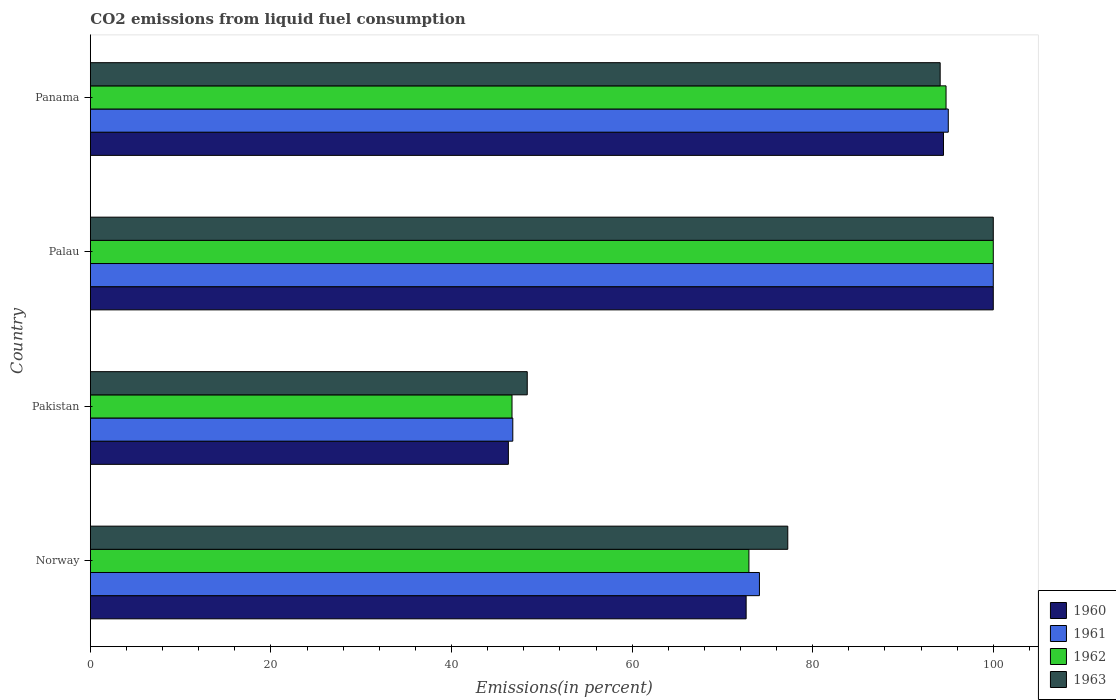How many different coloured bars are there?
Provide a short and direct response. 4. Are the number of bars per tick equal to the number of legend labels?
Provide a succinct answer. Yes. How many bars are there on the 1st tick from the bottom?
Provide a succinct answer. 4. In how many cases, is the number of bars for a given country not equal to the number of legend labels?
Provide a short and direct response. 0. What is the total CO2 emitted in 1960 in Norway?
Ensure brevity in your answer.  72.63. Across all countries, what is the maximum total CO2 emitted in 1960?
Provide a succinct answer. 100. Across all countries, what is the minimum total CO2 emitted in 1962?
Your response must be concise. 46.7. In which country was the total CO2 emitted in 1962 maximum?
Ensure brevity in your answer.  Palau. What is the total total CO2 emitted in 1962 in the graph?
Offer a very short reply. 314.4. What is the difference between the total CO2 emitted in 1962 in Norway and that in Pakistan?
Provide a short and direct response. 26.24. What is the difference between the total CO2 emitted in 1963 in Palau and the total CO2 emitted in 1960 in Norway?
Make the answer very short. 27.37. What is the average total CO2 emitted in 1960 per country?
Ensure brevity in your answer.  78.35. What is the difference between the total CO2 emitted in 1961 and total CO2 emitted in 1963 in Norway?
Your answer should be compact. -3.14. In how many countries, is the total CO2 emitted in 1962 greater than 44 %?
Offer a terse response. 4. What is the ratio of the total CO2 emitted in 1963 in Palau to that in Panama?
Make the answer very short. 1.06. What is the difference between the highest and the second highest total CO2 emitted in 1960?
Keep it short and to the point. 5.51. What is the difference between the highest and the lowest total CO2 emitted in 1962?
Ensure brevity in your answer.  53.3. What does the 2nd bar from the bottom in Norway represents?
Offer a very short reply. 1961. How many countries are there in the graph?
Keep it short and to the point. 4. What is the difference between two consecutive major ticks on the X-axis?
Your response must be concise. 20. Does the graph contain any zero values?
Give a very brief answer. No. How are the legend labels stacked?
Your answer should be compact. Vertical. What is the title of the graph?
Make the answer very short. CO2 emissions from liquid fuel consumption. Does "1964" appear as one of the legend labels in the graph?
Provide a succinct answer. No. What is the label or title of the X-axis?
Your response must be concise. Emissions(in percent). What is the label or title of the Y-axis?
Your answer should be very brief. Country. What is the Emissions(in percent) of 1960 in Norway?
Your answer should be very brief. 72.63. What is the Emissions(in percent) in 1961 in Norway?
Ensure brevity in your answer.  74.1. What is the Emissions(in percent) of 1962 in Norway?
Your response must be concise. 72.94. What is the Emissions(in percent) in 1963 in Norway?
Your response must be concise. 77.24. What is the Emissions(in percent) in 1960 in Pakistan?
Ensure brevity in your answer.  46.3. What is the Emissions(in percent) in 1961 in Pakistan?
Offer a terse response. 46.79. What is the Emissions(in percent) in 1962 in Pakistan?
Keep it short and to the point. 46.7. What is the Emissions(in percent) of 1963 in Pakistan?
Your response must be concise. 48.39. What is the Emissions(in percent) in 1960 in Palau?
Provide a short and direct response. 100. What is the Emissions(in percent) of 1962 in Palau?
Provide a succinct answer. 100. What is the Emissions(in percent) of 1963 in Palau?
Your answer should be compact. 100. What is the Emissions(in percent) of 1960 in Panama?
Your answer should be compact. 94.49. What is the Emissions(in percent) in 1961 in Panama?
Your answer should be very brief. 95.02. What is the Emissions(in percent) of 1962 in Panama?
Ensure brevity in your answer.  94.77. What is the Emissions(in percent) of 1963 in Panama?
Your response must be concise. 94.12. Across all countries, what is the maximum Emissions(in percent) in 1961?
Offer a very short reply. 100. Across all countries, what is the maximum Emissions(in percent) in 1962?
Your response must be concise. 100. Across all countries, what is the maximum Emissions(in percent) of 1963?
Ensure brevity in your answer.  100. Across all countries, what is the minimum Emissions(in percent) in 1960?
Your response must be concise. 46.3. Across all countries, what is the minimum Emissions(in percent) in 1961?
Your answer should be very brief. 46.79. Across all countries, what is the minimum Emissions(in percent) in 1962?
Your response must be concise. 46.7. Across all countries, what is the minimum Emissions(in percent) in 1963?
Make the answer very short. 48.39. What is the total Emissions(in percent) in 1960 in the graph?
Your response must be concise. 313.41. What is the total Emissions(in percent) in 1961 in the graph?
Your response must be concise. 315.9. What is the total Emissions(in percent) in 1962 in the graph?
Keep it short and to the point. 314.4. What is the total Emissions(in percent) of 1963 in the graph?
Offer a terse response. 319.74. What is the difference between the Emissions(in percent) in 1960 in Norway and that in Pakistan?
Your answer should be compact. 26.33. What is the difference between the Emissions(in percent) in 1961 in Norway and that in Pakistan?
Give a very brief answer. 27.32. What is the difference between the Emissions(in percent) of 1962 in Norway and that in Pakistan?
Offer a terse response. 26.24. What is the difference between the Emissions(in percent) in 1963 in Norway and that in Pakistan?
Your answer should be compact. 28.85. What is the difference between the Emissions(in percent) in 1960 in Norway and that in Palau?
Your answer should be compact. -27.37. What is the difference between the Emissions(in percent) in 1961 in Norway and that in Palau?
Offer a very short reply. -25.9. What is the difference between the Emissions(in percent) of 1962 in Norway and that in Palau?
Make the answer very short. -27.06. What is the difference between the Emissions(in percent) of 1963 in Norway and that in Palau?
Provide a succinct answer. -22.76. What is the difference between the Emissions(in percent) of 1960 in Norway and that in Panama?
Make the answer very short. -21.86. What is the difference between the Emissions(in percent) in 1961 in Norway and that in Panama?
Make the answer very short. -20.92. What is the difference between the Emissions(in percent) of 1962 in Norway and that in Panama?
Provide a short and direct response. -21.83. What is the difference between the Emissions(in percent) in 1963 in Norway and that in Panama?
Keep it short and to the point. -16.88. What is the difference between the Emissions(in percent) of 1960 in Pakistan and that in Palau?
Provide a succinct answer. -53.7. What is the difference between the Emissions(in percent) of 1961 in Pakistan and that in Palau?
Provide a succinct answer. -53.21. What is the difference between the Emissions(in percent) in 1962 in Pakistan and that in Palau?
Provide a short and direct response. -53.3. What is the difference between the Emissions(in percent) of 1963 in Pakistan and that in Palau?
Offer a very short reply. -51.61. What is the difference between the Emissions(in percent) of 1960 in Pakistan and that in Panama?
Offer a very short reply. -48.19. What is the difference between the Emissions(in percent) of 1961 in Pakistan and that in Panama?
Give a very brief answer. -48.23. What is the difference between the Emissions(in percent) in 1962 in Pakistan and that in Panama?
Your response must be concise. -48.07. What is the difference between the Emissions(in percent) of 1963 in Pakistan and that in Panama?
Your response must be concise. -45.73. What is the difference between the Emissions(in percent) in 1960 in Palau and that in Panama?
Ensure brevity in your answer.  5.51. What is the difference between the Emissions(in percent) in 1961 in Palau and that in Panama?
Give a very brief answer. 4.98. What is the difference between the Emissions(in percent) of 1962 in Palau and that in Panama?
Make the answer very short. 5.23. What is the difference between the Emissions(in percent) of 1963 in Palau and that in Panama?
Your answer should be very brief. 5.88. What is the difference between the Emissions(in percent) in 1960 in Norway and the Emissions(in percent) in 1961 in Pakistan?
Provide a succinct answer. 25.84. What is the difference between the Emissions(in percent) of 1960 in Norway and the Emissions(in percent) of 1962 in Pakistan?
Make the answer very short. 25.93. What is the difference between the Emissions(in percent) in 1960 in Norway and the Emissions(in percent) in 1963 in Pakistan?
Keep it short and to the point. 24.24. What is the difference between the Emissions(in percent) in 1961 in Norway and the Emissions(in percent) in 1962 in Pakistan?
Your answer should be compact. 27.4. What is the difference between the Emissions(in percent) of 1961 in Norway and the Emissions(in percent) of 1963 in Pakistan?
Give a very brief answer. 25.71. What is the difference between the Emissions(in percent) in 1962 in Norway and the Emissions(in percent) in 1963 in Pakistan?
Offer a terse response. 24.55. What is the difference between the Emissions(in percent) in 1960 in Norway and the Emissions(in percent) in 1961 in Palau?
Your answer should be compact. -27.37. What is the difference between the Emissions(in percent) in 1960 in Norway and the Emissions(in percent) in 1962 in Palau?
Offer a very short reply. -27.37. What is the difference between the Emissions(in percent) in 1960 in Norway and the Emissions(in percent) in 1963 in Palau?
Your answer should be compact. -27.37. What is the difference between the Emissions(in percent) in 1961 in Norway and the Emissions(in percent) in 1962 in Palau?
Your answer should be compact. -25.9. What is the difference between the Emissions(in percent) of 1961 in Norway and the Emissions(in percent) of 1963 in Palau?
Your response must be concise. -25.9. What is the difference between the Emissions(in percent) of 1962 in Norway and the Emissions(in percent) of 1963 in Palau?
Your answer should be very brief. -27.06. What is the difference between the Emissions(in percent) in 1960 in Norway and the Emissions(in percent) in 1961 in Panama?
Make the answer very short. -22.39. What is the difference between the Emissions(in percent) of 1960 in Norway and the Emissions(in percent) of 1962 in Panama?
Your answer should be very brief. -22.14. What is the difference between the Emissions(in percent) of 1960 in Norway and the Emissions(in percent) of 1963 in Panama?
Your answer should be very brief. -21.49. What is the difference between the Emissions(in percent) in 1961 in Norway and the Emissions(in percent) in 1962 in Panama?
Your answer should be compact. -20.67. What is the difference between the Emissions(in percent) of 1961 in Norway and the Emissions(in percent) of 1963 in Panama?
Provide a short and direct response. -20.02. What is the difference between the Emissions(in percent) of 1962 in Norway and the Emissions(in percent) of 1963 in Panama?
Make the answer very short. -21.18. What is the difference between the Emissions(in percent) in 1960 in Pakistan and the Emissions(in percent) in 1961 in Palau?
Offer a terse response. -53.7. What is the difference between the Emissions(in percent) of 1960 in Pakistan and the Emissions(in percent) of 1962 in Palau?
Your answer should be very brief. -53.7. What is the difference between the Emissions(in percent) of 1960 in Pakistan and the Emissions(in percent) of 1963 in Palau?
Your answer should be compact. -53.7. What is the difference between the Emissions(in percent) of 1961 in Pakistan and the Emissions(in percent) of 1962 in Palau?
Ensure brevity in your answer.  -53.21. What is the difference between the Emissions(in percent) in 1961 in Pakistan and the Emissions(in percent) in 1963 in Palau?
Keep it short and to the point. -53.21. What is the difference between the Emissions(in percent) in 1962 in Pakistan and the Emissions(in percent) in 1963 in Palau?
Make the answer very short. -53.3. What is the difference between the Emissions(in percent) of 1960 in Pakistan and the Emissions(in percent) of 1961 in Panama?
Ensure brevity in your answer.  -48.72. What is the difference between the Emissions(in percent) of 1960 in Pakistan and the Emissions(in percent) of 1962 in Panama?
Your response must be concise. -48.47. What is the difference between the Emissions(in percent) in 1960 in Pakistan and the Emissions(in percent) in 1963 in Panama?
Provide a short and direct response. -47.82. What is the difference between the Emissions(in percent) in 1961 in Pakistan and the Emissions(in percent) in 1962 in Panama?
Offer a very short reply. -47.98. What is the difference between the Emissions(in percent) of 1961 in Pakistan and the Emissions(in percent) of 1963 in Panama?
Offer a very short reply. -47.33. What is the difference between the Emissions(in percent) of 1962 in Pakistan and the Emissions(in percent) of 1963 in Panama?
Your answer should be very brief. -47.42. What is the difference between the Emissions(in percent) of 1960 in Palau and the Emissions(in percent) of 1961 in Panama?
Ensure brevity in your answer.  4.98. What is the difference between the Emissions(in percent) in 1960 in Palau and the Emissions(in percent) in 1962 in Panama?
Your response must be concise. 5.23. What is the difference between the Emissions(in percent) in 1960 in Palau and the Emissions(in percent) in 1963 in Panama?
Your response must be concise. 5.88. What is the difference between the Emissions(in percent) in 1961 in Palau and the Emissions(in percent) in 1962 in Panama?
Provide a short and direct response. 5.23. What is the difference between the Emissions(in percent) in 1961 in Palau and the Emissions(in percent) in 1963 in Panama?
Your response must be concise. 5.88. What is the difference between the Emissions(in percent) of 1962 in Palau and the Emissions(in percent) of 1963 in Panama?
Keep it short and to the point. 5.88. What is the average Emissions(in percent) in 1960 per country?
Ensure brevity in your answer.  78.35. What is the average Emissions(in percent) in 1961 per country?
Your answer should be compact. 78.98. What is the average Emissions(in percent) in 1962 per country?
Your response must be concise. 78.6. What is the average Emissions(in percent) of 1963 per country?
Ensure brevity in your answer.  79.94. What is the difference between the Emissions(in percent) of 1960 and Emissions(in percent) of 1961 in Norway?
Ensure brevity in your answer.  -1.47. What is the difference between the Emissions(in percent) of 1960 and Emissions(in percent) of 1962 in Norway?
Give a very brief answer. -0.31. What is the difference between the Emissions(in percent) of 1960 and Emissions(in percent) of 1963 in Norway?
Offer a terse response. -4.61. What is the difference between the Emissions(in percent) in 1961 and Emissions(in percent) in 1962 in Norway?
Give a very brief answer. 1.16. What is the difference between the Emissions(in percent) in 1961 and Emissions(in percent) in 1963 in Norway?
Your answer should be compact. -3.14. What is the difference between the Emissions(in percent) in 1962 and Emissions(in percent) in 1963 in Norway?
Your answer should be compact. -4.3. What is the difference between the Emissions(in percent) of 1960 and Emissions(in percent) of 1961 in Pakistan?
Provide a short and direct response. -0.49. What is the difference between the Emissions(in percent) of 1960 and Emissions(in percent) of 1962 in Pakistan?
Offer a terse response. -0.4. What is the difference between the Emissions(in percent) in 1960 and Emissions(in percent) in 1963 in Pakistan?
Offer a very short reply. -2.09. What is the difference between the Emissions(in percent) of 1961 and Emissions(in percent) of 1962 in Pakistan?
Give a very brief answer. 0.09. What is the difference between the Emissions(in percent) in 1961 and Emissions(in percent) in 1963 in Pakistan?
Ensure brevity in your answer.  -1.6. What is the difference between the Emissions(in percent) of 1962 and Emissions(in percent) of 1963 in Pakistan?
Offer a very short reply. -1.69. What is the difference between the Emissions(in percent) in 1960 and Emissions(in percent) in 1961 in Panama?
Keep it short and to the point. -0.53. What is the difference between the Emissions(in percent) of 1960 and Emissions(in percent) of 1962 in Panama?
Make the answer very short. -0.28. What is the difference between the Emissions(in percent) in 1960 and Emissions(in percent) in 1963 in Panama?
Provide a short and direct response. 0.37. What is the difference between the Emissions(in percent) in 1961 and Emissions(in percent) in 1962 in Panama?
Your answer should be compact. 0.25. What is the difference between the Emissions(in percent) of 1961 and Emissions(in percent) of 1963 in Panama?
Provide a short and direct response. 0.9. What is the difference between the Emissions(in percent) in 1962 and Emissions(in percent) in 1963 in Panama?
Your answer should be compact. 0.65. What is the ratio of the Emissions(in percent) of 1960 in Norway to that in Pakistan?
Give a very brief answer. 1.57. What is the ratio of the Emissions(in percent) in 1961 in Norway to that in Pakistan?
Ensure brevity in your answer.  1.58. What is the ratio of the Emissions(in percent) in 1962 in Norway to that in Pakistan?
Your response must be concise. 1.56. What is the ratio of the Emissions(in percent) of 1963 in Norway to that in Pakistan?
Offer a terse response. 1.6. What is the ratio of the Emissions(in percent) of 1960 in Norway to that in Palau?
Offer a very short reply. 0.73. What is the ratio of the Emissions(in percent) in 1961 in Norway to that in Palau?
Your answer should be compact. 0.74. What is the ratio of the Emissions(in percent) of 1962 in Norway to that in Palau?
Make the answer very short. 0.73. What is the ratio of the Emissions(in percent) of 1963 in Norway to that in Palau?
Offer a terse response. 0.77. What is the ratio of the Emissions(in percent) in 1960 in Norway to that in Panama?
Give a very brief answer. 0.77. What is the ratio of the Emissions(in percent) of 1961 in Norway to that in Panama?
Ensure brevity in your answer.  0.78. What is the ratio of the Emissions(in percent) in 1962 in Norway to that in Panama?
Give a very brief answer. 0.77. What is the ratio of the Emissions(in percent) of 1963 in Norway to that in Panama?
Offer a very short reply. 0.82. What is the ratio of the Emissions(in percent) of 1960 in Pakistan to that in Palau?
Ensure brevity in your answer.  0.46. What is the ratio of the Emissions(in percent) of 1961 in Pakistan to that in Palau?
Provide a succinct answer. 0.47. What is the ratio of the Emissions(in percent) in 1962 in Pakistan to that in Palau?
Make the answer very short. 0.47. What is the ratio of the Emissions(in percent) in 1963 in Pakistan to that in Palau?
Offer a terse response. 0.48. What is the ratio of the Emissions(in percent) of 1960 in Pakistan to that in Panama?
Provide a short and direct response. 0.49. What is the ratio of the Emissions(in percent) in 1961 in Pakistan to that in Panama?
Offer a terse response. 0.49. What is the ratio of the Emissions(in percent) of 1962 in Pakistan to that in Panama?
Keep it short and to the point. 0.49. What is the ratio of the Emissions(in percent) of 1963 in Pakistan to that in Panama?
Offer a very short reply. 0.51. What is the ratio of the Emissions(in percent) in 1960 in Palau to that in Panama?
Make the answer very short. 1.06. What is the ratio of the Emissions(in percent) in 1961 in Palau to that in Panama?
Offer a very short reply. 1.05. What is the ratio of the Emissions(in percent) in 1962 in Palau to that in Panama?
Give a very brief answer. 1.06. What is the ratio of the Emissions(in percent) of 1963 in Palau to that in Panama?
Offer a terse response. 1.06. What is the difference between the highest and the second highest Emissions(in percent) in 1960?
Make the answer very short. 5.51. What is the difference between the highest and the second highest Emissions(in percent) in 1961?
Offer a terse response. 4.98. What is the difference between the highest and the second highest Emissions(in percent) of 1962?
Your answer should be compact. 5.23. What is the difference between the highest and the second highest Emissions(in percent) in 1963?
Keep it short and to the point. 5.88. What is the difference between the highest and the lowest Emissions(in percent) of 1960?
Ensure brevity in your answer.  53.7. What is the difference between the highest and the lowest Emissions(in percent) in 1961?
Offer a terse response. 53.21. What is the difference between the highest and the lowest Emissions(in percent) of 1962?
Offer a very short reply. 53.3. What is the difference between the highest and the lowest Emissions(in percent) of 1963?
Your response must be concise. 51.61. 